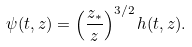<formula> <loc_0><loc_0><loc_500><loc_500>\psi ( t , z ) = \left ( \frac { z _ { * } } { z } \right ) ^ { 3 / 2 } h ( t , z ) .</formula> 